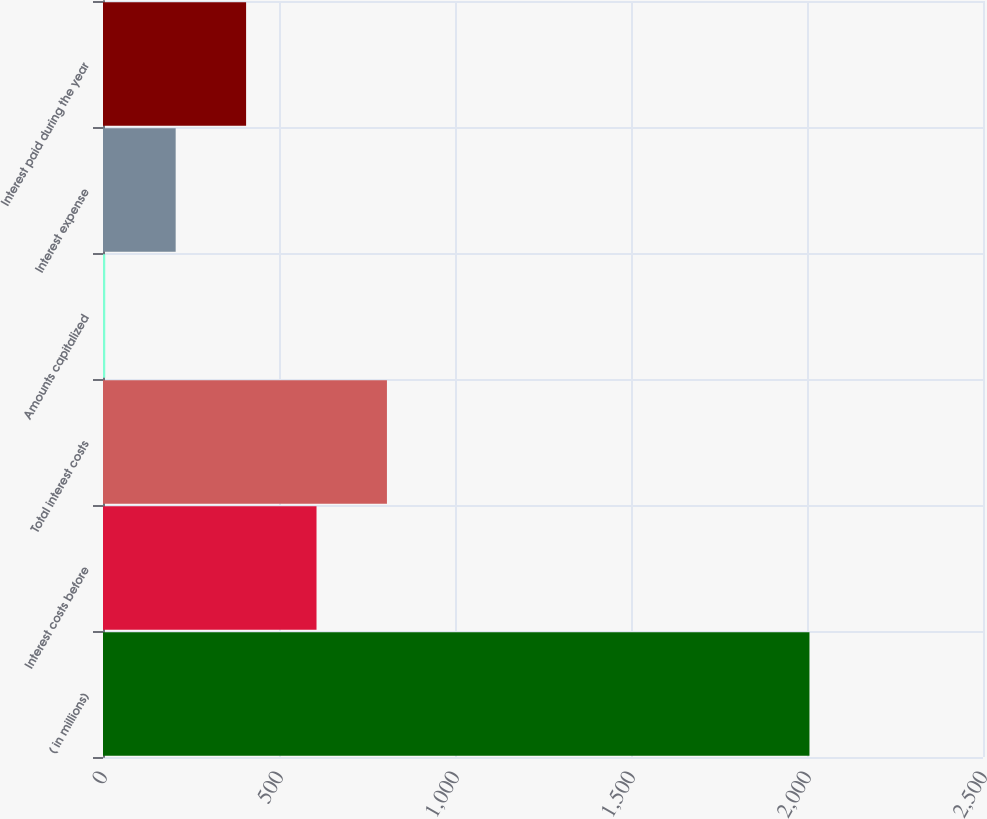Convert chart to OTSL. <chart><loc_0><loc_0><loc_500><loc_500><bar_chart><fcel>( in millions)<fcel>Interest costs before<fcel>Total interest costs<fcel>Amounts capitalized<fcel>Interest expense<fcel>Interest paid during the year<nl><fcel>2007<fcel>606.58<fcel>806.64<fcel>6.4<fcel>206.46<fcel>406.52<nl></chart> 